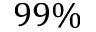Convert formula to latex. <formula><loc_0><loc_0><loc_500><loc_500>9 9 \%</formula> 